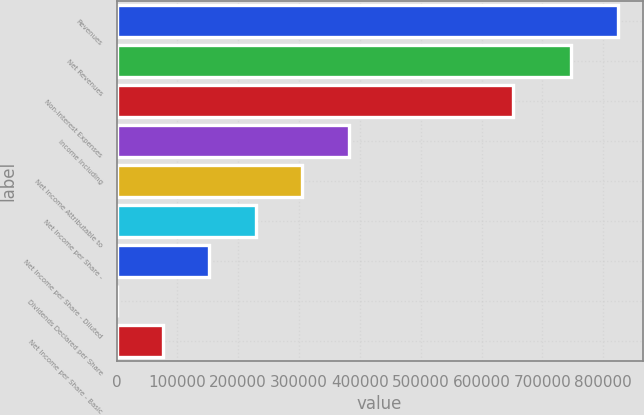Convert chart. <chart><loc_0><loc_0><loc_500><loc_500><bar_chart><fcel>Revenues<fcel>Net Revenues<fcel>Non-Interest Expenses<fcel>Income Including<fcel>Net Income Attributable to<fcel>Net Income per Share -<fcel>Net Income per Share - Diluted<fcel>Dividends Declared per Share<fcel>Net Income per Share - Basic<nl><fcel>823734<fcel>747373<fcel>652026<fcel>381806<fcel>305445<fcel>229084<fcel>152722<fcel>0.11<fcel>76361.3<nl></chart> 